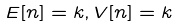Convert formula to latex. <formula><loc_0><loc_0><loc_500><loc_500>E [ n ] = k , V [ n ] = k</formula> 